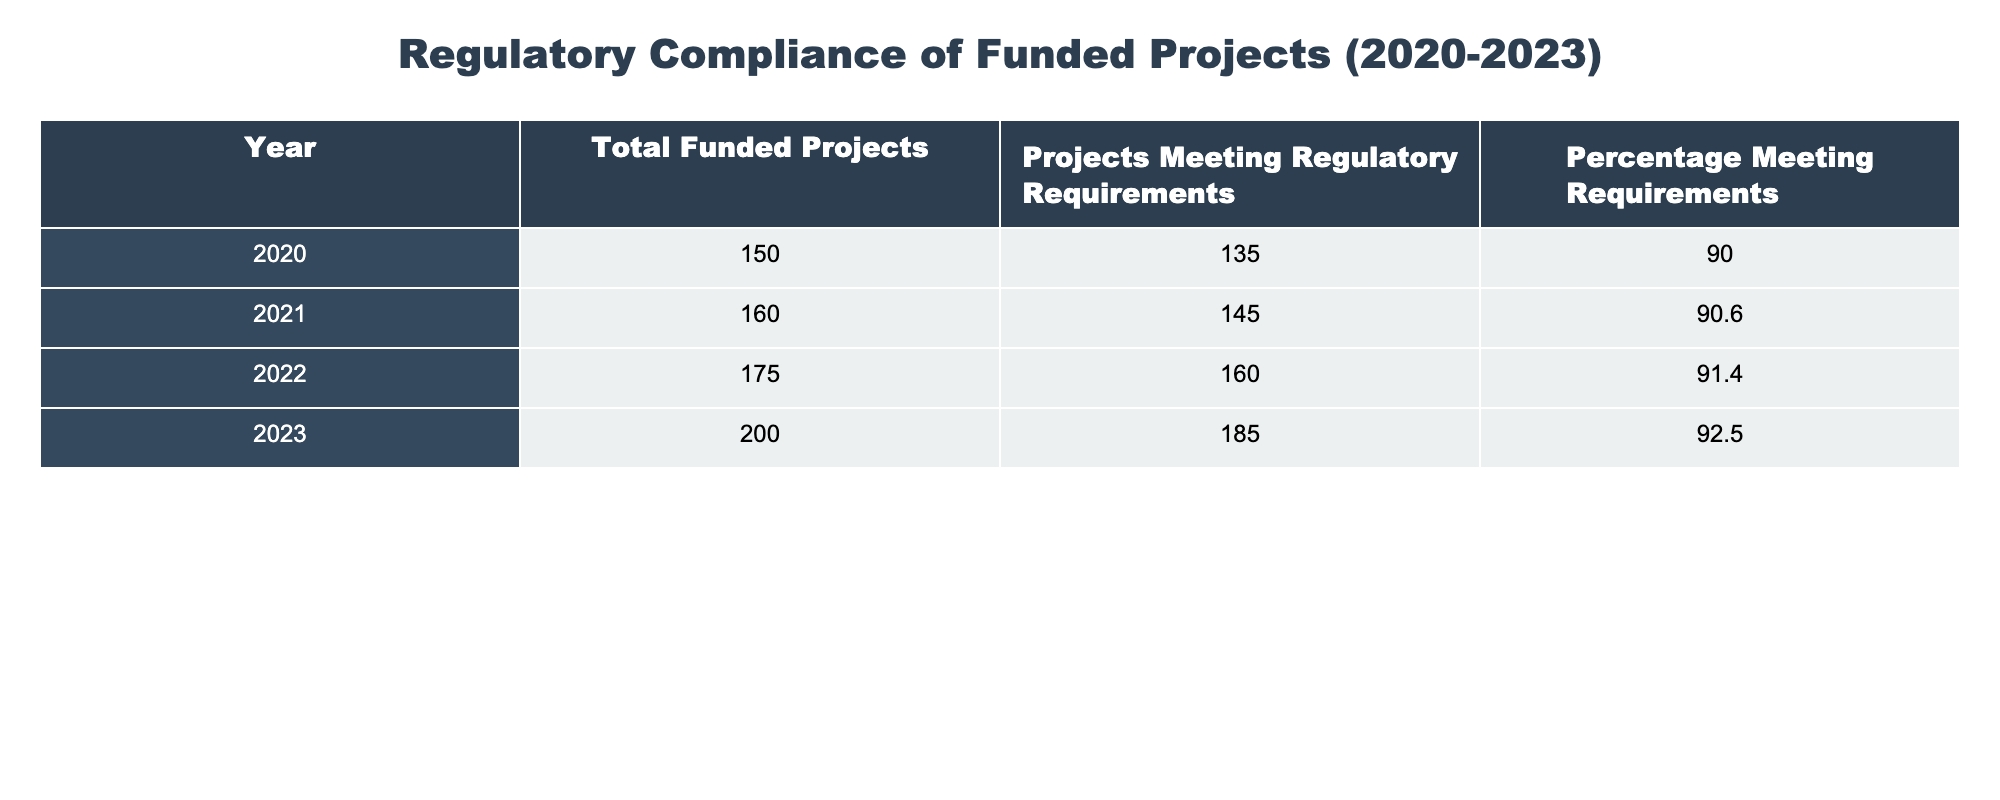What was the total number of funded projects in 2021? From the table, we can directly refer to the row for the year 2021 and see that the number of total funded projects is listed as 160.
Answer: 160 What was the percentage of projects meeting regulatory requirements in 2022? The table specifies that for the year 2022, the percentage of projects meeting regulatory requirements is 91.4%.
Answer: 91.4% How many projects met regulatory requirements in 2023? In the row for 2023, the table indicates that 185 projects met the regulatory requirements.
Answer: 185 What is the average percentage of projects meeting regulatory requirements from 2020 to 2023? We can calculate the average by adding the percentages from all four years: (90.0 + 90.6 + 91.4 + 92.5) = 364.5. Then, divide by 4 for the average: 364.5 / 4 = 91.125.
Answer: 91.125 Was there an increase in the percentage of projects meeting regulatory requirements from 2021 to 2022? In the table, the percentage in 2021 is 90.6% and in 2022 it is 91.4%. Since 91.4% is greater than 90.6%, there was indeed an increase.
Answer: Yes How many more projects met regulatory requirements in 2023 compared to 2020? From the table, 185 projects met the requirements in 2023, and 135 met them in 2020. By calculating the difference: 185 - 135 = 50, we find that 50 more projects met the requirements in 2023 compared to 2020.
Answer: 50 Is it true that the total number of funded projects increased every year from 2020 to 2023? Looking at the values in the table, the total funded projects were 150 in 2020, 160 in 2021, 175 in 2022, and 200 in 2023. Since each year shows an increase, the statement is true.
Answer: True Which year had the highest number of funded projects? By examining the total funded projects for each year, we see that 2023 had the highest number with 200 projects.
Answer: 2023 What was the difference between the percentage of projects meeting regulatory requirements in 2020 and 2023? The percentage in 2020 was 90.0% and in 2023 it was 92.5%. The difference can be calculated as 92.5 - 90.0 = 2.5%.
Answer: 2.5 